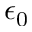<formula> <loc_0><loc_0><loc_500><loc_500>\epsilon _ { 0 }</formula> 